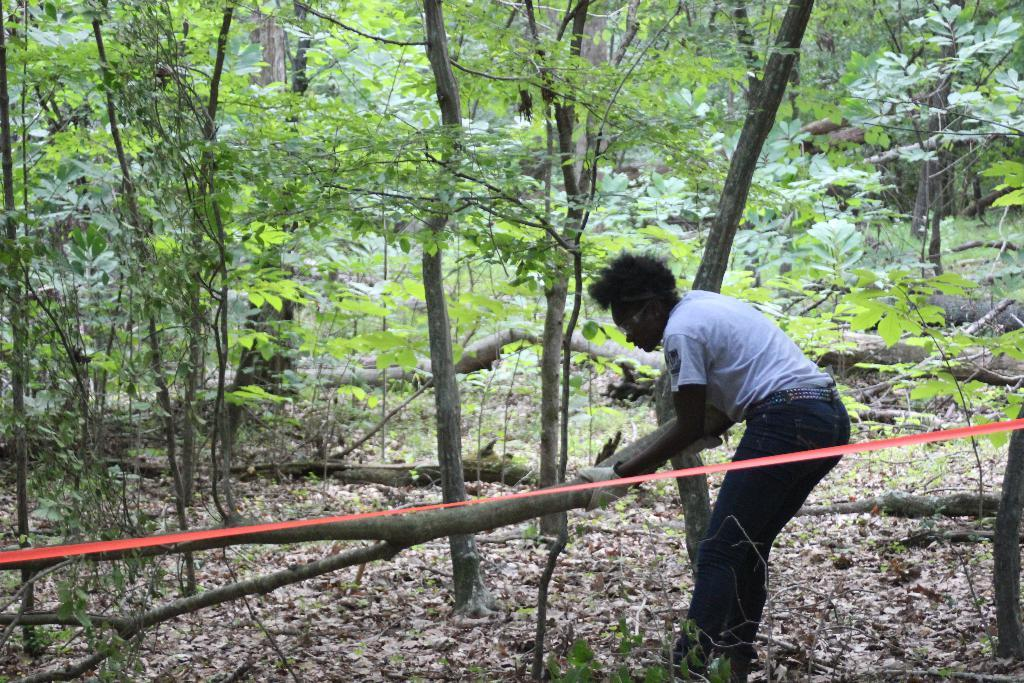What is the color of the ribbon in the image? The ribbon in the image is red. What is the person in the image doing? The person is standing and holding a branch. What can be seen in the background of the image? There are plants and trees in the background of the image. How many sheep are visible in the image? There are no sheep present in the image. What type of horn is attached to the person's head in the image? There is no horn present on the person's head in the image. 